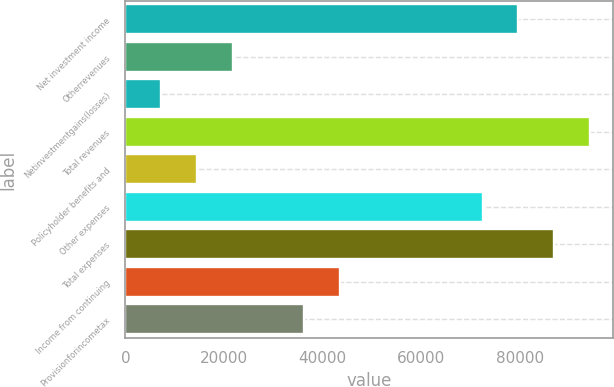Convert chart. <chart><loc_0><loc_0><loc_500><loc_500><bar_chart><fcel>Net investment income<fcel>Otherrevenues<fcel>Netinvestmentgains(losses)<fcel>Total revenues<fcel>Policyholder benefits and<fcel>Other expenses<fcel>Total expenses<fcel>Income from continuing<fcel>Provisionforincometax<nl><fcel>79665.6<fcel>21732.8<fcel>7249.6<fcel>94148.8<fcel>14491.2<fcel>72424<fcel>86907.2<fcel>43457.6<fcel>36216<nl></chart> 